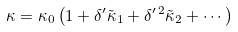Convert formula to latex. <formula><loc_0><loc_0><loc_500><loc_500>\kappa = \kappa _ { 0 } \left ( 1 + \delta ^ { \prime } \tilde { \kappa } _ { 1 } + \delta ^ { \prime \, 2 } \tilde { \kappa } _ { 2 } + \cdots \right )</formula> 